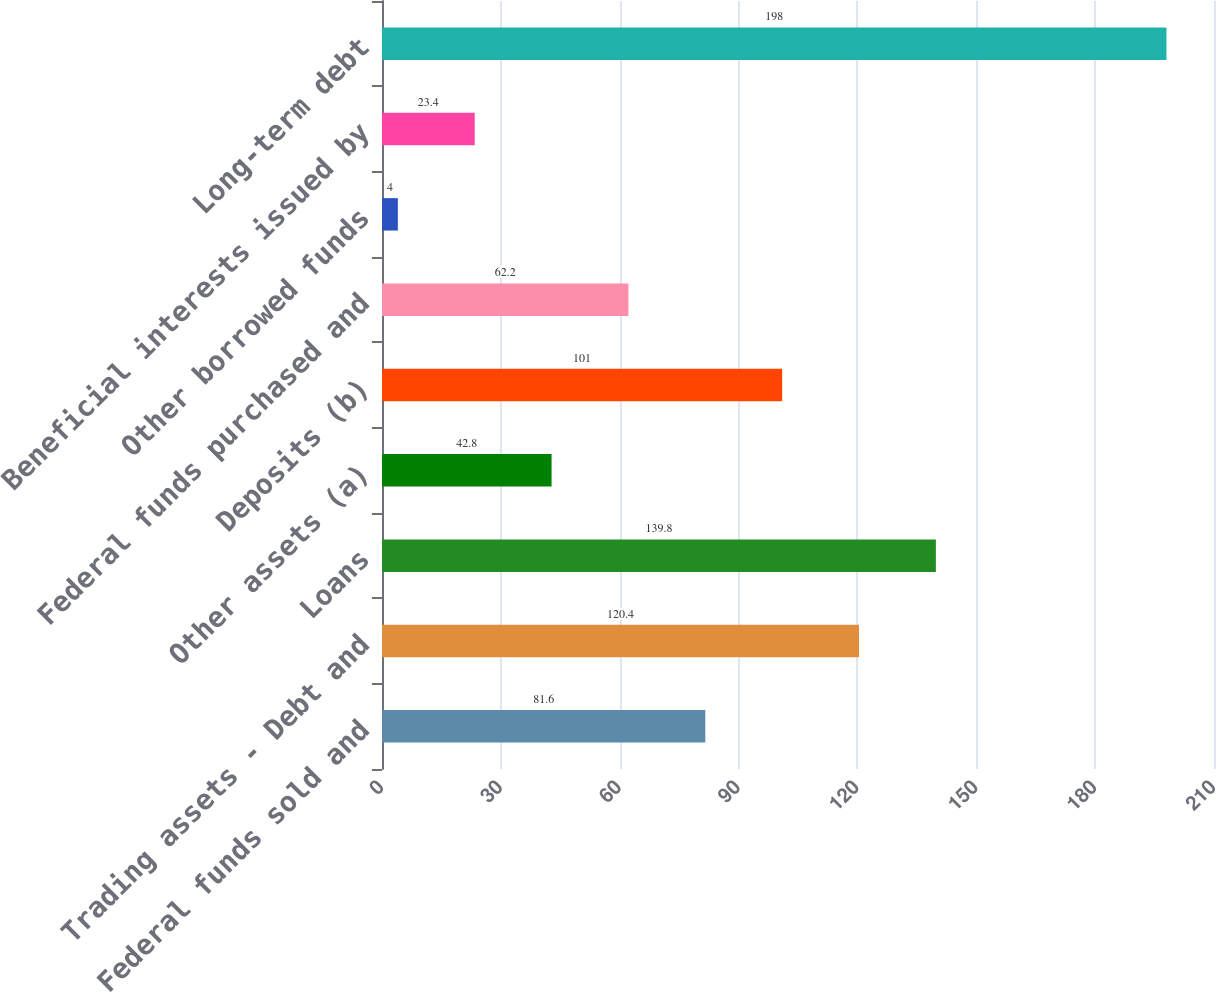<chart> <loc_0><loc_0><loc_500><loc_500><bar_chart><fcel>Federal funds sold and<fcel>Trading assets - Debt and<fcel>Loans<fcel>Other assets (a)<fcel>Deposits (b)<fcel>Federal funds purchased and<fcel>Other borrowed funds<fcel>Beneficial interests issued by<fcel>Long-term debt<nl><fcel>81.6<fcel>120.4<fcel>139.8<fcel>42.8<fcel>101<fcel>62.2<fcel>4<fcel>23.4<fcel>198<nl></chart> 